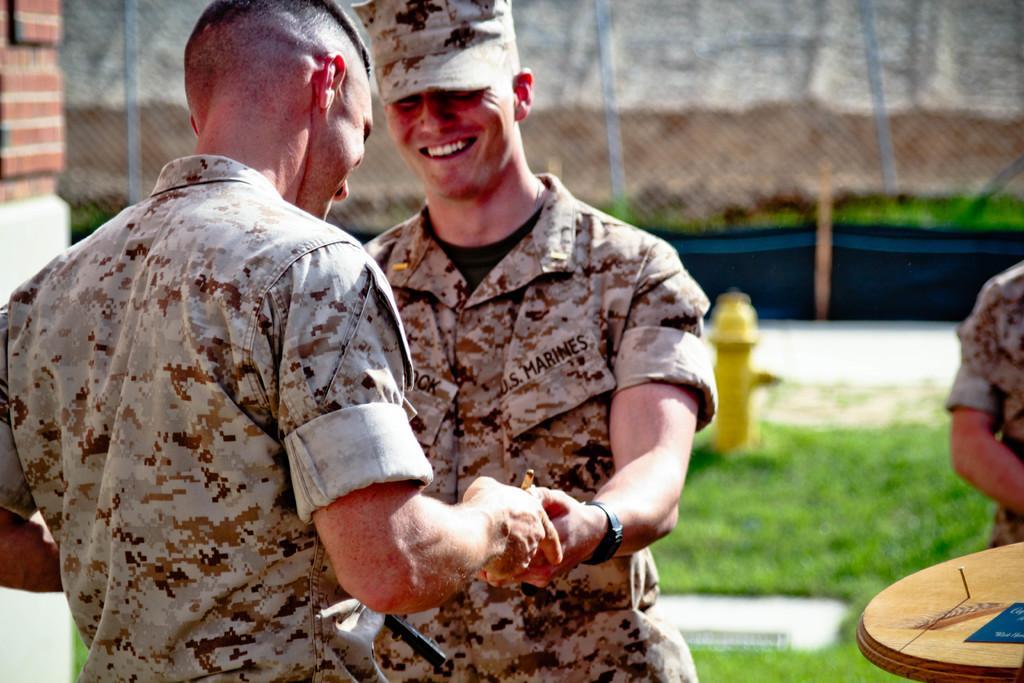Describe this image in one or two sentences. These three persons are standing and these two persons are smiling and holding hands each other and this person wear cap. On the background we can see fence,grass. We can see table. 